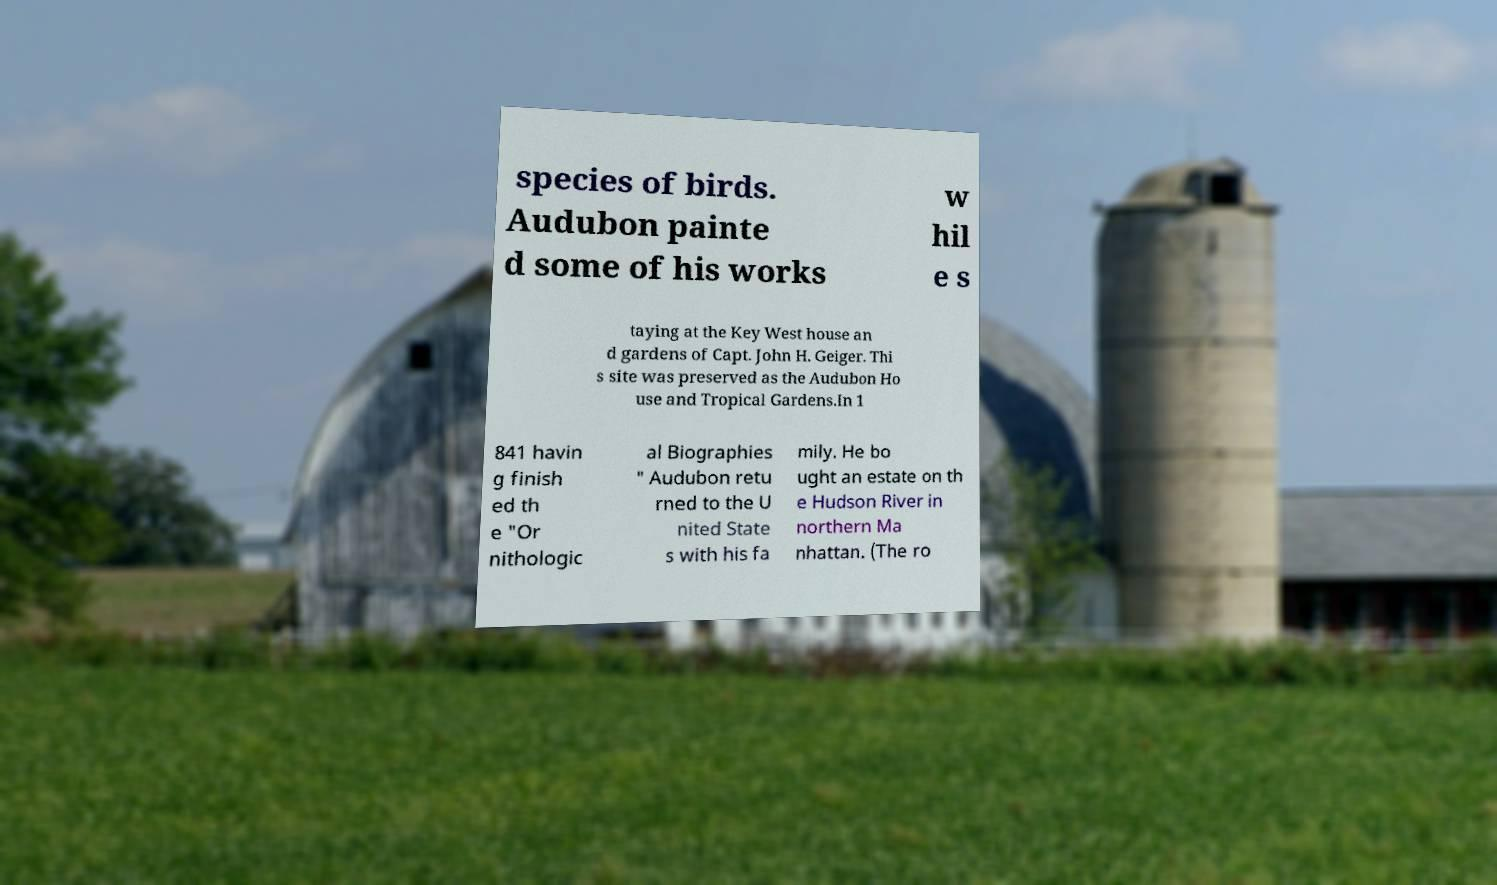Please identify and transcribe the text found in this image. species of birds. Audubon painte d some of his works w hil e s taying at the Key West house an d gardens of Capt. John H. Geiger. Thi s site was preserved as the Audubon Ho use and Tropical Gardens.In 1 841 havin g finish ed th e "Or nithologic al Biographies " Audubon retu rned to the U nited State s with his fa mily. He bo ught an estate on th e Hudson River in northern Ma nhattan. (The ro 